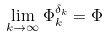Convert formula to latex. <formula><loc_0><loc_0><loc_500><loc_500>\lim _ { k \to \infty } \Phi ^ { \delta _ { k } } _ { k } = \Phi</formula> 